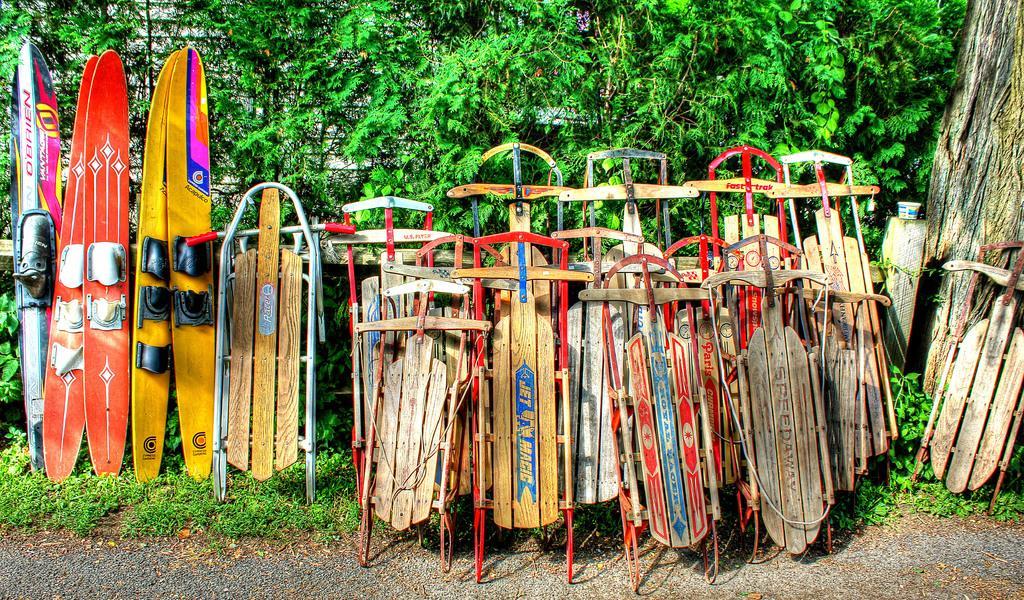Describe this image in one or two sentences. In this picture, it seems like surfing boats in the foreground area and greenery in the background. 